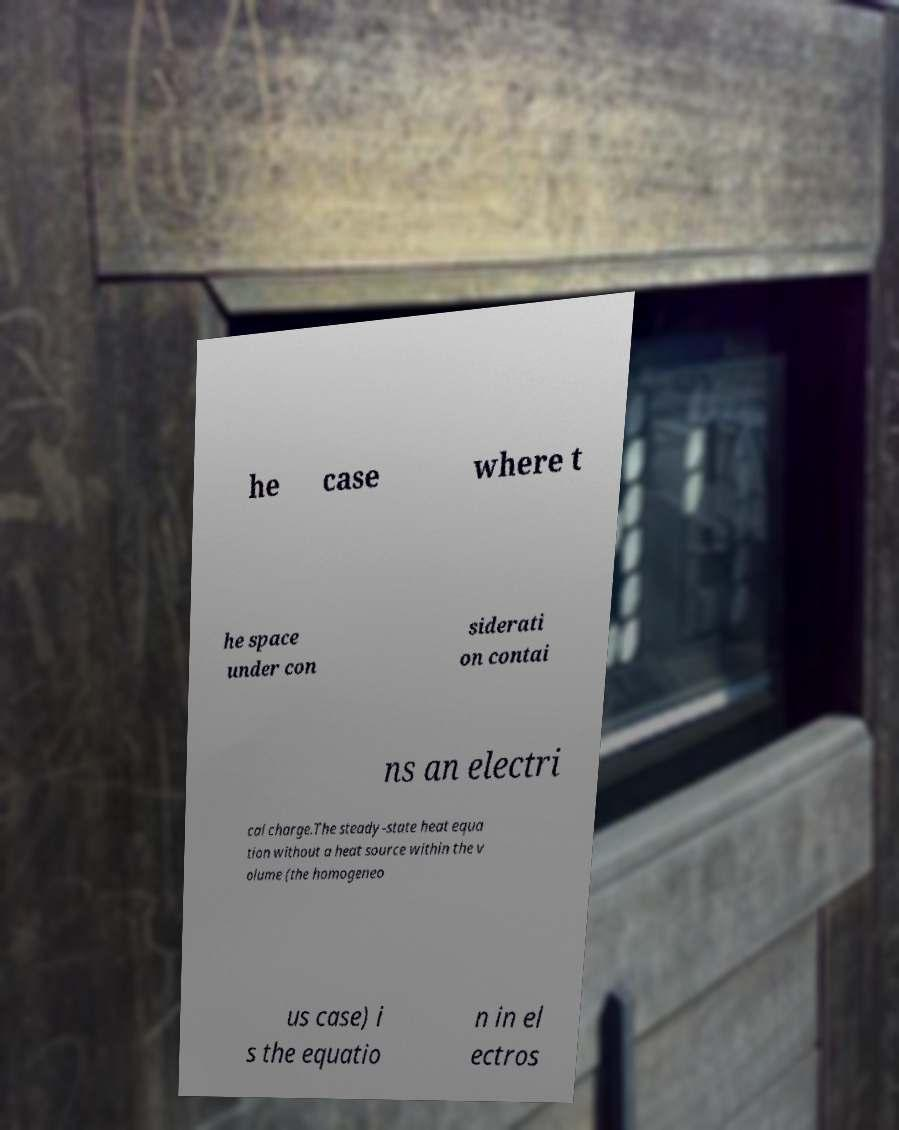Please read and relay the text visible in this image. What does it say? he case where t he space under con siderati on contai ns an electri cal charge.The steady-state heat equa tion without a heat source within the v olume (the homogeneo us case) i s the equatio n in el ectros 